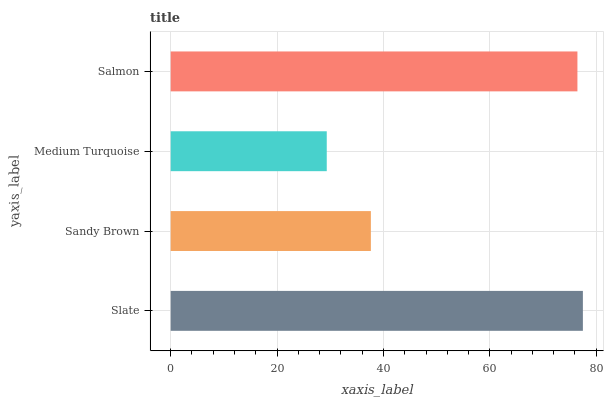Is Medium Turquoise the minimum?
Answer yes or no. Yes. Is Slate the maximum?
Answer yes or no. Yes. Is Sandy Brown the minimum?
Answer yes or no. No. Is Sandy Brown the maximum?
Answer yes or no. No. Is Slate greater than Sandy Brown?
Answer yes or no. Yes. Is Sandy Brown less than Slate?
Answer yes or no. Yes. Is Sandy Brown greater than Slate?
Answer yes or no. No. Is Slate less than Sandy Brown?
Answer yes or no. No. Is Salmon the high median?
Answer yes or no. Yes. Is Sandy Brown the low median?
Answer yes or no. Yes. Is Slate the high median?
Answer yes or no. No. Is Slate the low median?
Answer yes or no. No. 